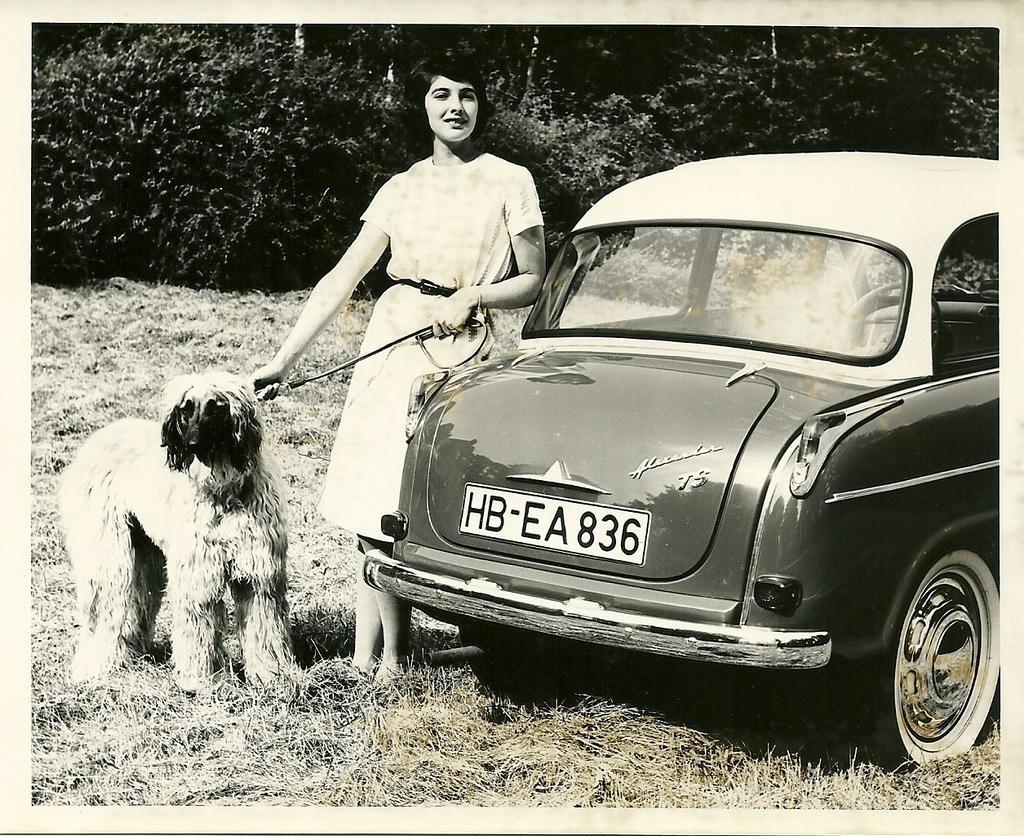Could you give a brief overview of what you see in this image? This is a black and white picture. On the background we can see trees. This is a grass. We can see a car. Aside to that a woman is standing holding a belt of a dog. 